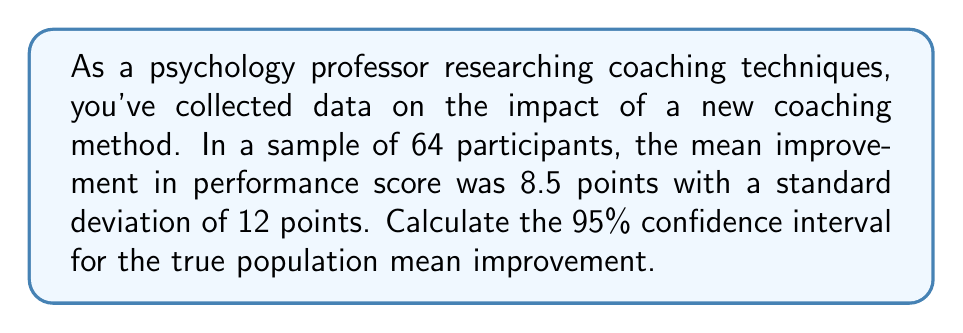Can you answer this question? To calculate the confidence interval, we'll follow these steps:

1) The formula for the confidence interval is:

   $$ \bar{x} \pm t_{\alpha/2} \cdot \frac{s}{\sqrt{n}} $$

   where $\bar{x}$ is the sample mean, $s$ is the sample standard deviation, $n$ is the sample size, and $t_{\alpha/2}$ is the t-value for the desired confidence level.

2) We know:
   $\bar{x} = 8.5$
   $s = 12$
   $n = 64$
   Confidence level = 95%, so $\alpha = 0.05$

3) For a 95% confidence interval with 63 degrees of freedom (n-1), the t-value is approximately 1.998 (from t-distribution table).

4) Calculate the margin of error:

   $$ \text{Margin of Error} = t_{\alpha/2} \cdot \frac{s}{\sqrt{n}} = 1.998 \cdot \frac{12}{\sqrt{64}} = 1.998 \cdot 1.5 = 2.997 $$

5) Calculate the confidence interval:

   $$ 8.5 \pm 2.997 $$

6) Therefore, the 95% confidence interval is:

   $$ (8.5 - 2.997, 8.5 + 2.997) = (5.503, 11.497) $$
Answer: (5.503, 11.497) 